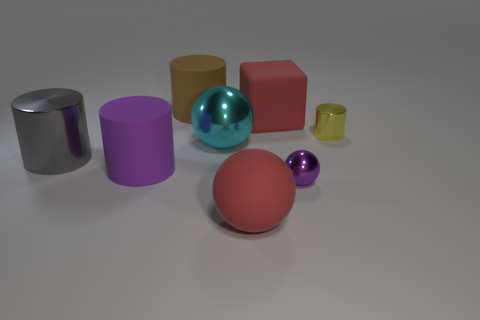Add 1 big matte things. How many objects exist? 9 Subtract all balls. How many objects are left? 5 Add 1 small yellow cylinders. How many small yellow cylinders exist? 2 Subtract 1 red blocks. How many objects are left? 7 Subtract all large purple shiny cubes. Subtract all big metallic balls. How many objects are left? 7 Add 4 small yellow objects. How many small yellow objects are left? 5 